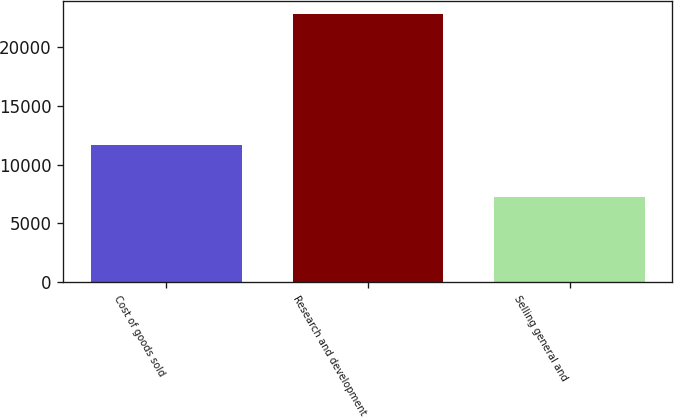Convert chart. <chart><loc_0><loc_0><loc_500><loc_500><bar_chart><fcel>Cost of goods sold<fcel>Research and development<fcel>Selling general and<nl><fcel>11668<fcel>22799<fcel>7249<nl></chart> 